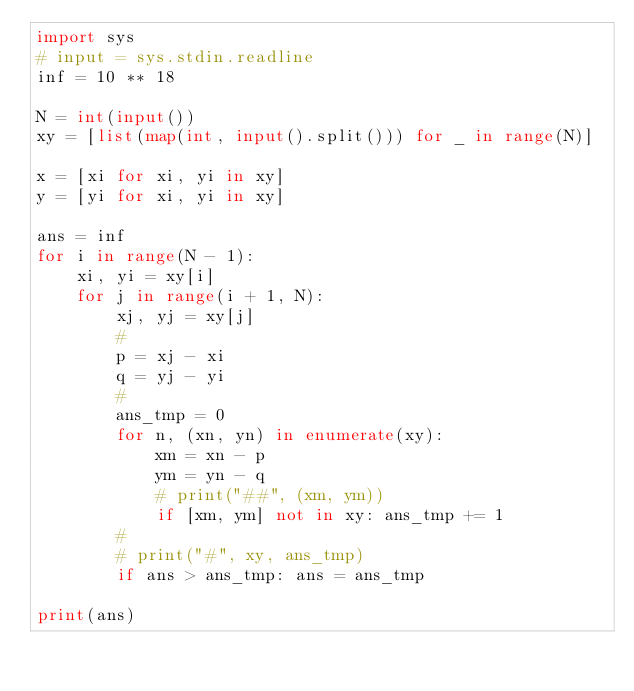<code> <loc_0><loc_0><loc_500><loc_500><_Python_>import sys
# input = sys.stdin.readline
inf = 10 ** 18

N = int(input())
xy = [list(map(int, input().split())) for _ in range(N)]

x = [xi for xi, yi in xy]
y = [yi for xi, yi in xy]

ans = inf
for i in range(N - 1):
    xi, yi = xy[i]
    for j in range(i + 1, N):
        xj, yj = xy[j]
        #
        p = xj - xi
        q = yj - yi
        #
        ans_tmp = 0
        for n, (xn, yn) in enumerate(xy):
            xm = xn - p
            ym = yn - q
            # print("##", (xm, ym))
            if [xm, ym] not in xy: ans_tmp += 1
        #
        # print("#", xy, ans_tmp)
        if ans > ans_tmp: ans = ans_tmp

print(ans)</code> 